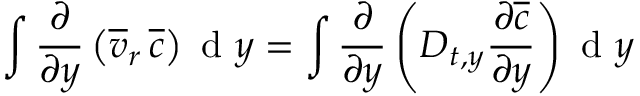Convert formula to latex. <formula><loc_0><loc_0><loc_500><loc_500>\int \frac { \partial } { \partial y } \left ( \overline { v } _ { r } \, \overline { c } \right ) d y = \int \frac { \partial } { \partial y } \left ( D _ { t , y } \frac { \partial \overline { c } } { \partial y } \right ) d y</formula> 